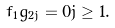<formula> <loc_0><loc_0><loc_500><loc_500>f _ { 1 } g _ { 2 j } = 0 j \geq 1 .</formula> 